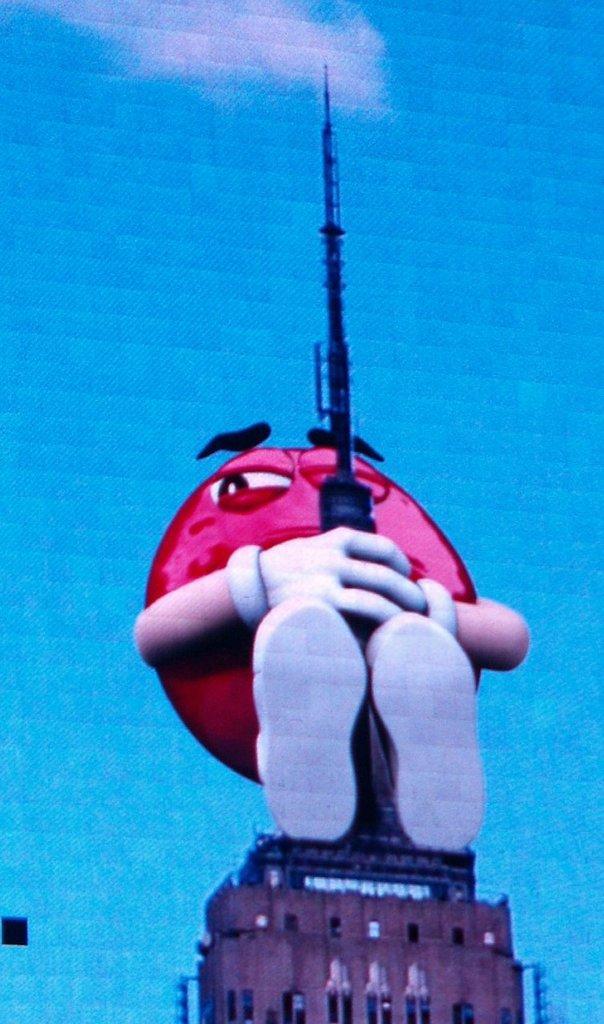In one or two sentences, can you explain what this image depicts? This is an edited image. At the bottom there is a building. On this building there is an edited emoji which is in pink color and holding an object in the hands. The background is in blue color. 